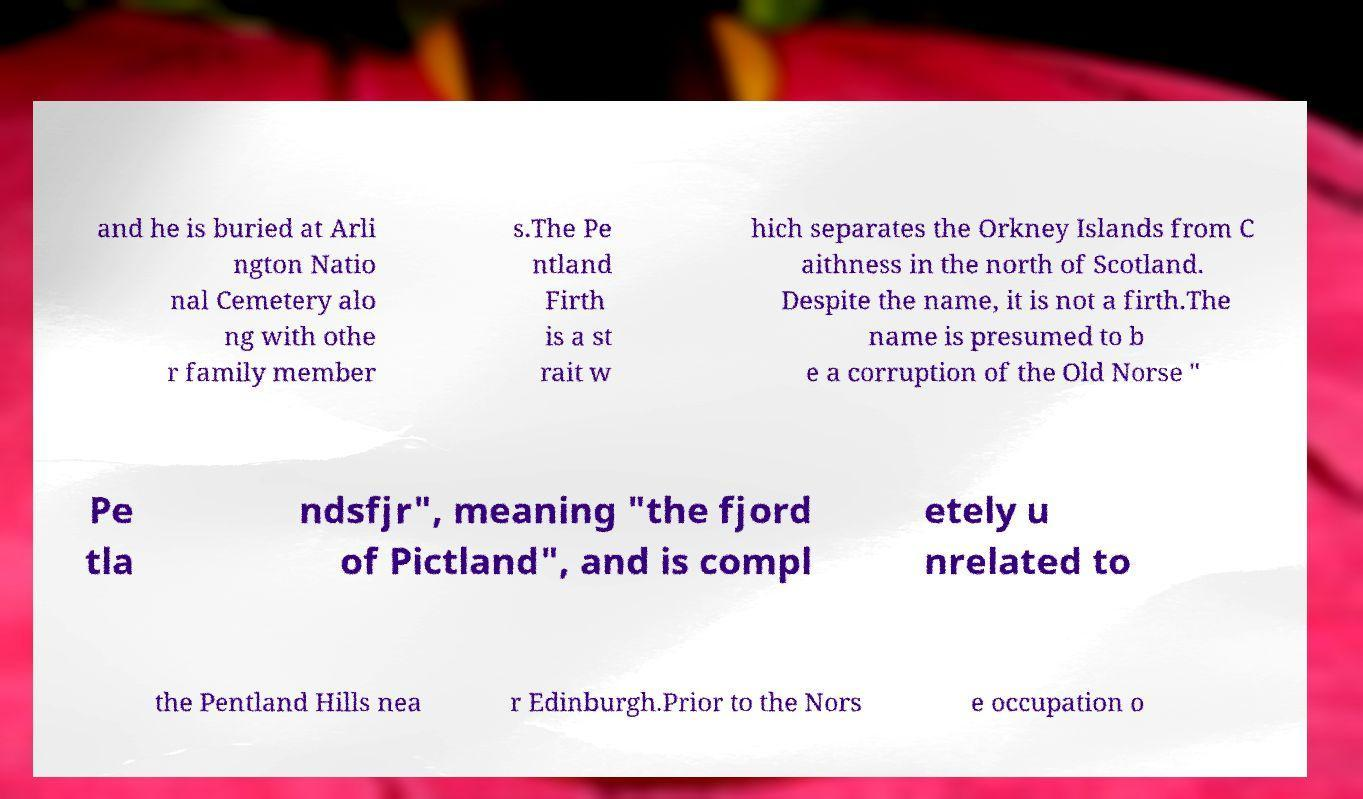Could you extract and type out the text from this image? and he is buried at Arli ngton Natio nal Cemetery alo ng with othe r family member s.The Pe ntland Firth is a st rait w hich separates the Orkney Islands from C aithness in the north of Scotland. Despite the name, it is not a firth.The name is presumed to b e a corruption of the Old Norse " Pe tla ndsfjr", meaning "the fjord of Pictland", and is compl etely u nrelated to the Pentland Hills nea r Edinburgh.Prior to the Nors e occupation o 